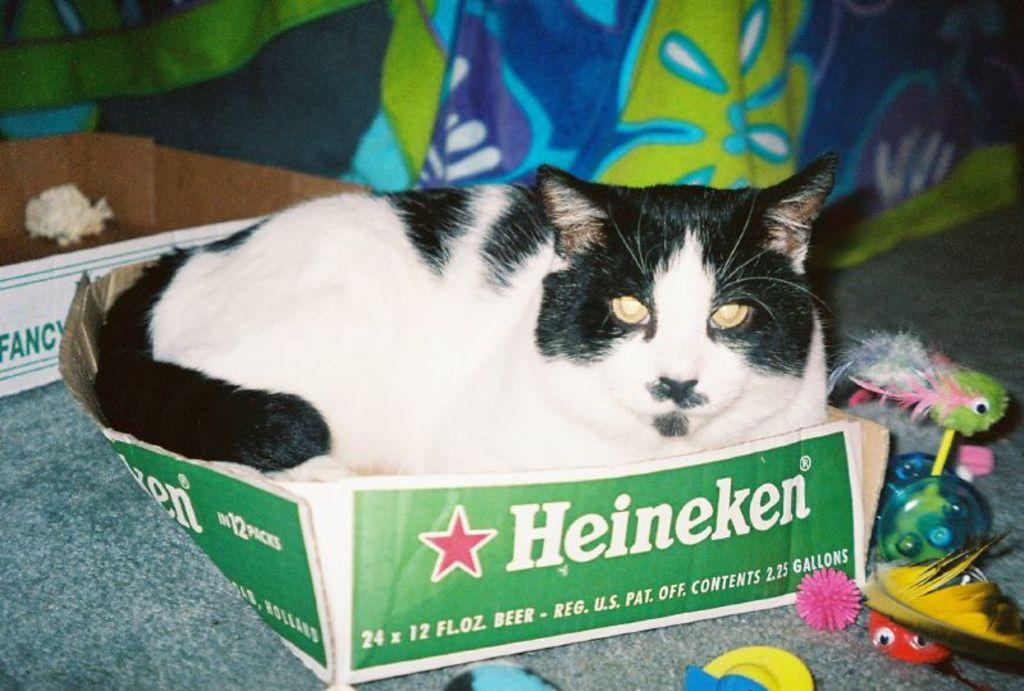<image>
Create a compact narrative representing the image presented. A black and white cat lays in a Heineken box. 